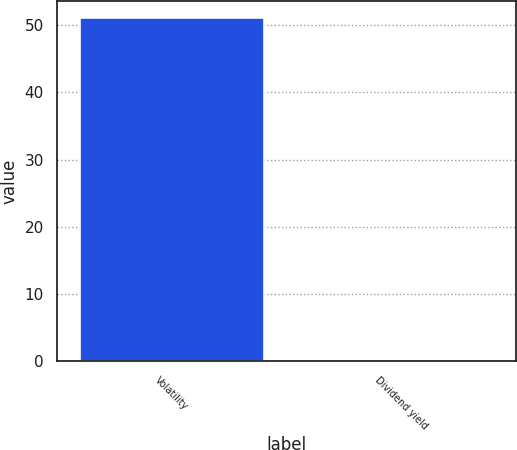<chart> <loc_0><loc_0><loc_500><loc_500><bar_chart><fcel>Volatility<fcel>Dividend yield<nl><fcel>51<fcel>0.25<nl></chart> 